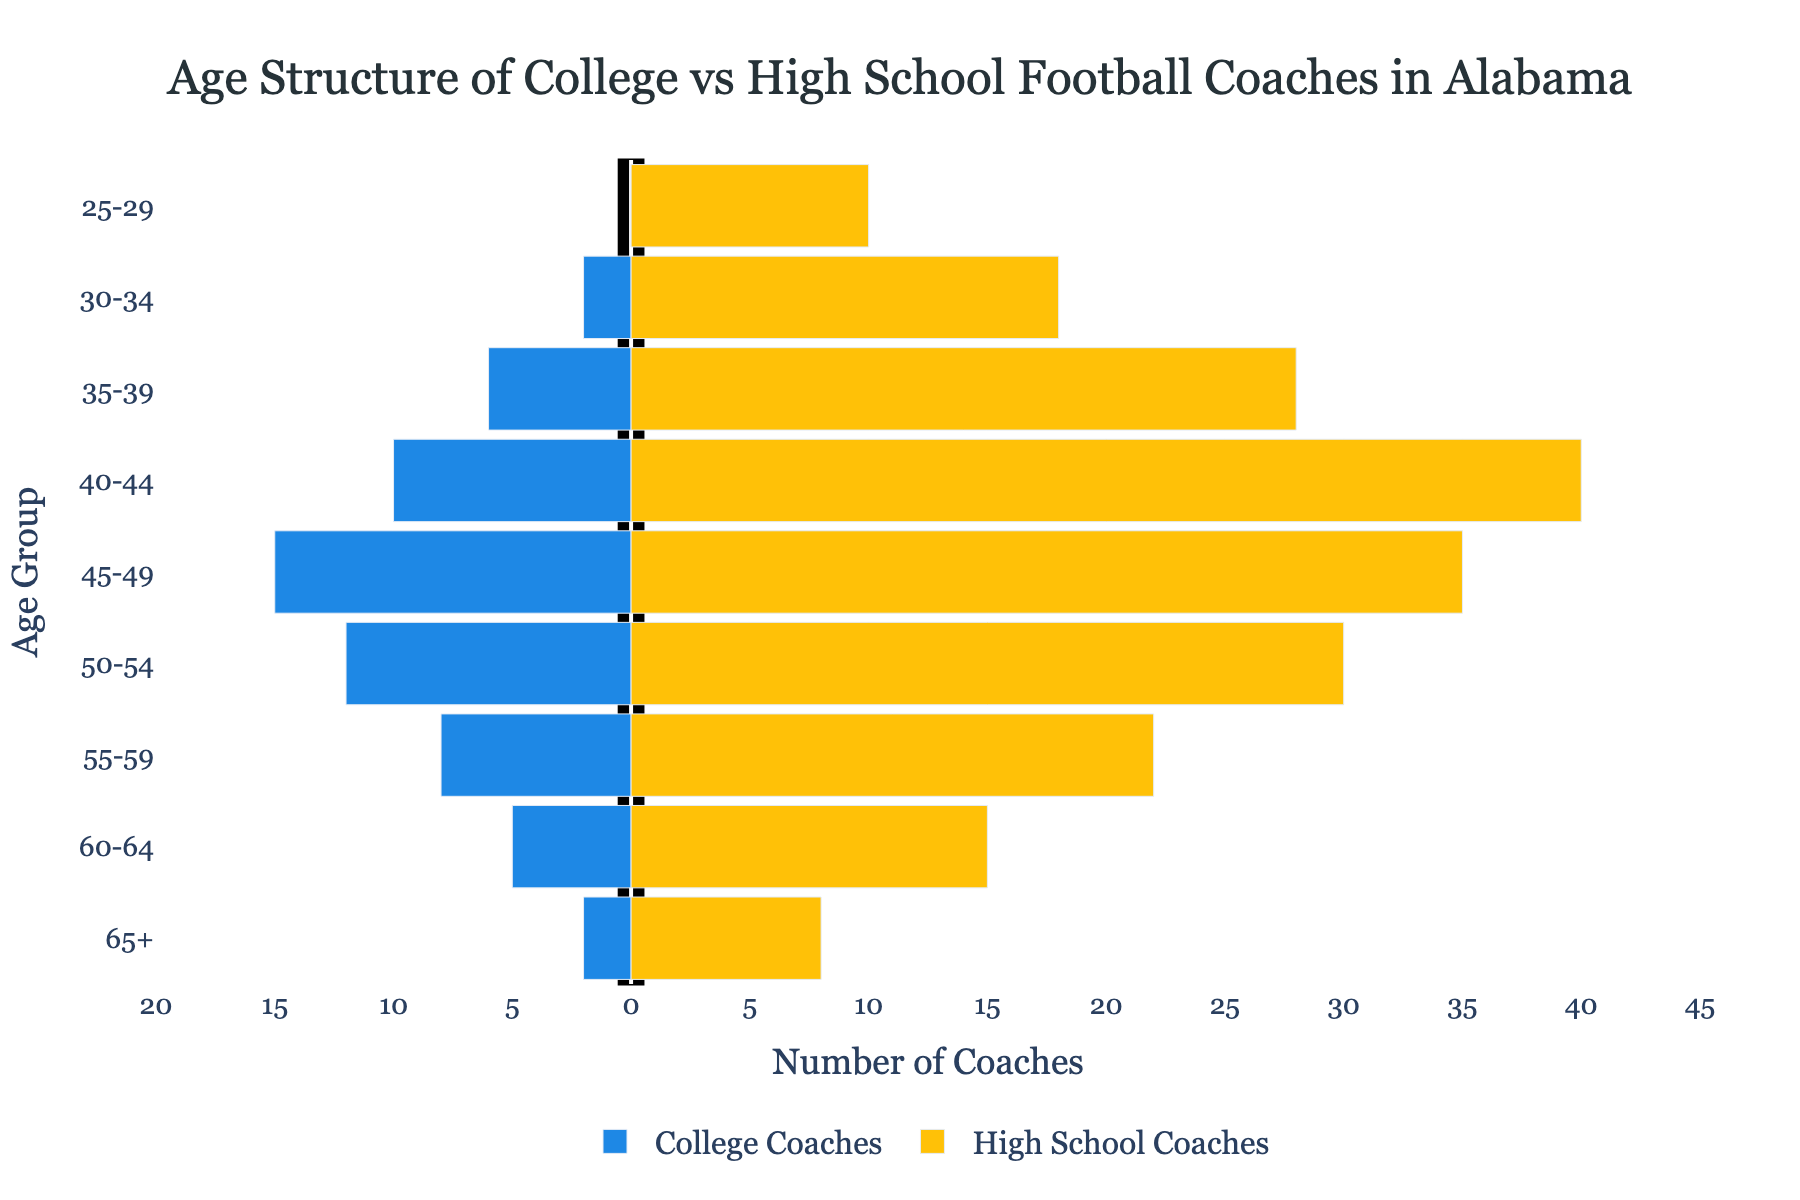What is the title of the figure? The title of the figure is written clearly at the top of the chart. It is used to describe the content and focus of the visualization.
Answer: Age Structure of College vs High School Football Coaches in Alabama What colors are used to represent the College Coaches and High School Coaches? The colors representing the different categories are specified in the legend at the bottom of the figure.
Answer: Blue for College Coaches and Yellow for High School Coaches How many age groups are displayed on the y-axis? The y-axis lists the age groups. By counting them, we can determine the answer.
Answer: 9 Which age group has the highest number of High School Coaches? By visually inspecting the length of the yellow bars on the right side of the pyramid, the longest bar indicates the age group.
Answer: 40-44 How many more High School Coaches are there in the 50-54 age group compared to College Coaches? The number of High School Coaches in the 50-54 age group is 30 and the number of College Coaches is 12. Subtract the smaller number from the bigger number.
Answer: 18 What is the total number of High School Coaches across all age groups? Sum the values of High School Coaches for each age group: 8 + 15 + 22 + 30 + 35 + 40 + 28 + 18 + 10 = 206
Answer: 206 What is the average number of College Coaches per age group? Sum the values of College Coaches and divide by the number of age groups: (2 + 5 + 8 + 12 + 15 + 10 + 6 + 2 + 0) / 9 = 60 / 9 ≈ 6.67
Answer: 6.67 In which age group do the College Coaches surpass the High School Coaches? By visually comparing both sides of the pyramid, look for age groups where the blue bars (left side) are longer than the yellow bars (right side).
Answer: None In the 65+ age group, how many more High School Coaches are there compared to College Coaches? The number of High School Coaches in the 65+ age group is 8 and the number of College Coaches is 2. Subtract the smaller number from the bigger number.
Answer: 6 